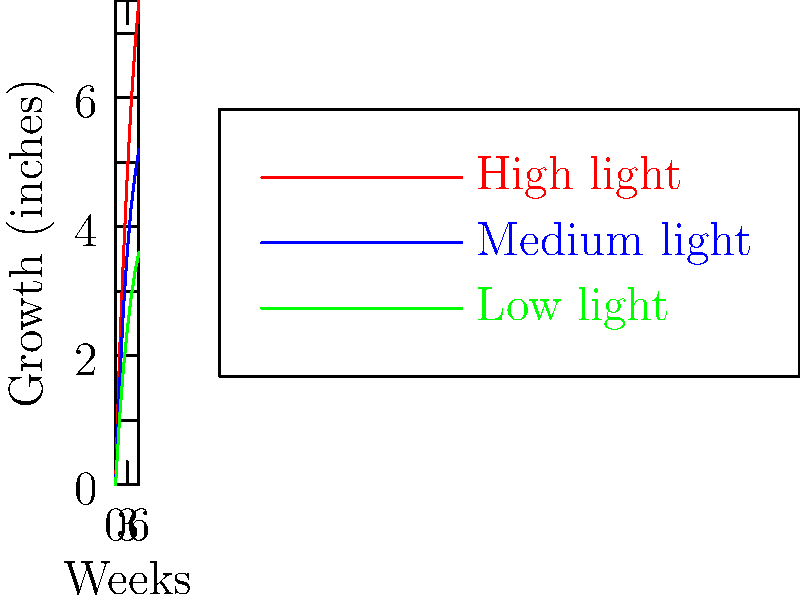Based on the graph showing the growth of indoor plants under different light conditions, what is the approximate difference in growth (in inches) between high-light and low-light conditions after 6 weeks? To find the difference in growth between high-light and low-light conditions after 6 weeks:

1. Locate the 6-week mark on the x-axis.
2. Find the corresponding growth values for high-light (red line) and low-light (green line) conditions:
   - High-light: approximately 7.5 inches
   - Low-light: approximately 3.6 inches
3. Calculate the difference:
   $7.5 - 3.6 = 3.9$ inches

The difference in growth between high-light and low-light conditions after 6 weeks is approximately 3.9 inches.
Answer: 3.9 inches 